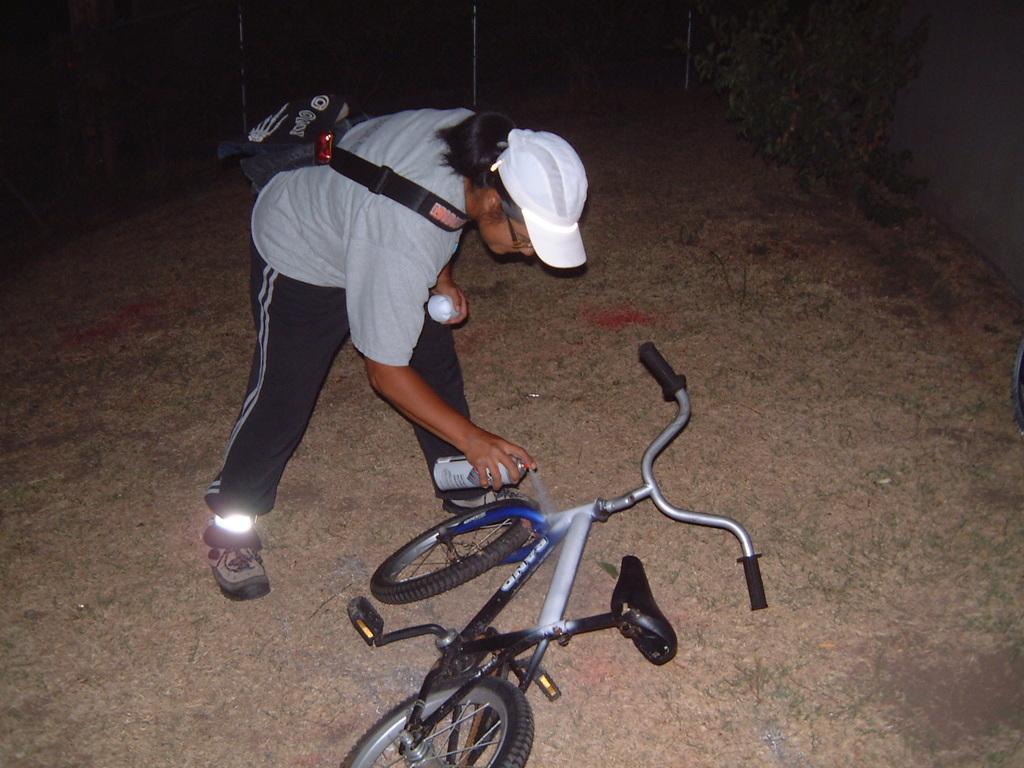Can you describe this image briefly? At the bottom of the image there is a ground. In the middle of the ground there is a cycle. Behind the cycle there is a lady with grey t-shirt, white cap on her head and also there is a bag. She is holding the bottle in her hand and she is spraying on the cycle. At the top right of the image there is a tree. 